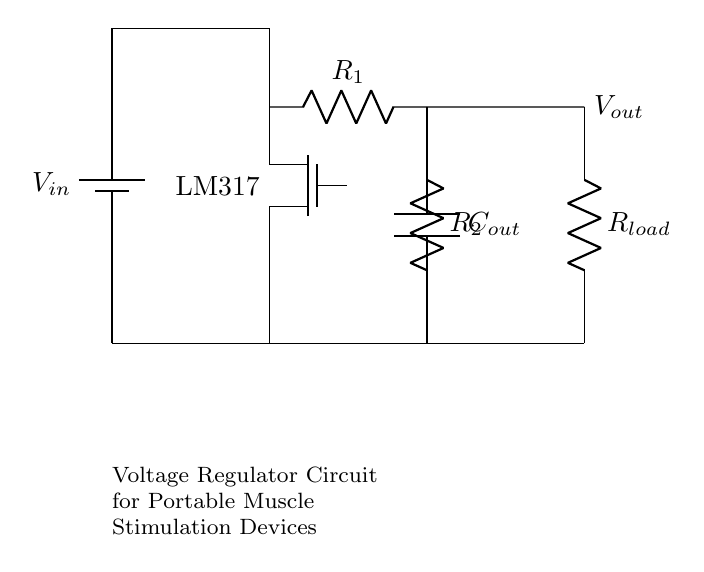What is the input voltage of the circuit? The input voltage is denoted as V_in, which is the voltage supplied by the battery in the circuit.
Answer: V_in What type of component is used as the voltage regulator? The voltage regulator in this circuit is labeled as LM317, which is a specific type of adjustable voltage regulator IC commonly used for providing stable output voltage.
Answer: LM317 What are the values of R1 and R2? The circuit diagram shows resistors R1 and R2, but their specific values are not indicated in the diagram; they are typically determined based on the desired output voltage.
Answer: Not specified What is the purpose of capacitor C_out? Capacitor C_out is used to filter and stabilize the output voltage by smoothing out the fluctuations caused by changes in load or input voltage.
Answer: Smoothing Which component is connected to the output? The output is connected to a resistor load, labeled as R_load, which represents the external device or circuit that receives the regulated output voltage.
Answer: R_load What is the function of the NMOS transistor in the circuit? The NMOS transistor (labeled as nmos) is used in this voltage regulator circuit to control the flow of current, effectively varying the output voltage based on the feedback received from the load.
Answer: Current control How does this circuit help in muscle stimulation devices? This circuit regulates the voltage to a specific safe level for portable muscle stimulation devices, ensuring proper functioning without risking damage or injury.
Answer: Voltage regulation 